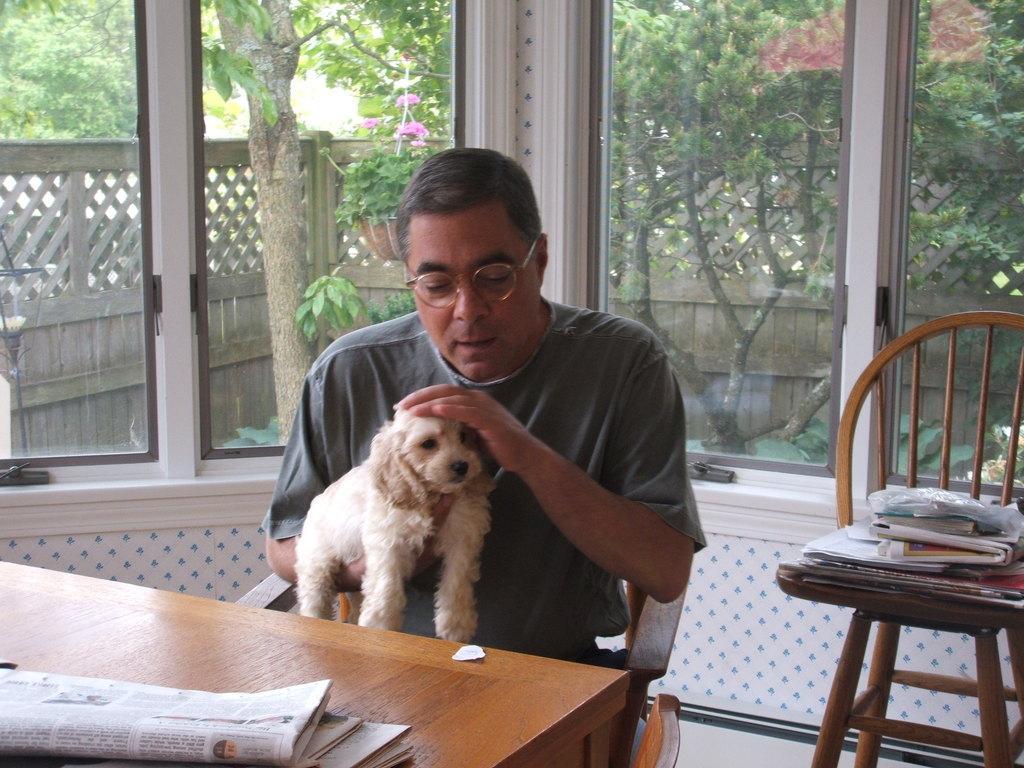Could you give a brief overview of what you see in this image? In this image the man is sitting on the chair and the man is holding a dog. On the table there is a paper. At the background there are trees. 